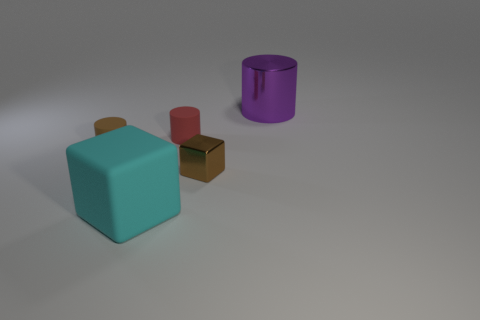Subtract all big shiny cylinders. How many cylinders are left? 2 Add 1 tiny red cylinders. How many objects exist? 6 Subtract all cyan blocks. How many blocks are left? 1 Subtract all cylinders. How many objects are left? 2 Subtract all green balls. How many cyan blocks are left? 1 Subtract all tiny things. Subtract all gray rubber cylinders. How many objects are left? 2 Add 1 tiny brown things. How many tiny brown things are left? 3 Add 3 cylinders. How many cylinders exist? 6 Subtract 1 cyan blocks. How many objects are left? 4 Subtract 1 cylinders. How many cylinders are left? 2 